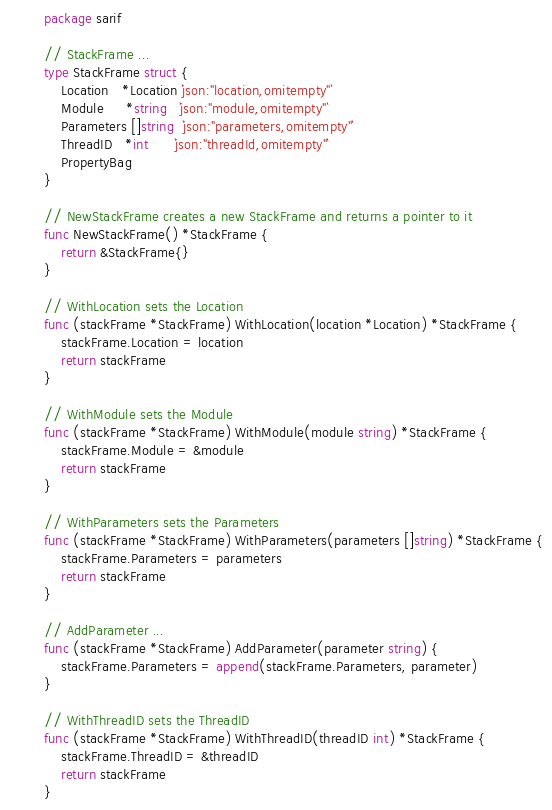Convert code to text. <code><loc_0><loc_0><loc_500><loc_500><_Go_>package sarif

// StackFrame ...
type StackFrame struct {
	Location   *Location `json:"location,omitempty"`
	Module     *string   `json:"module,omitempty"`
	Parameters []string  `json:"parameters,omitempty"`
	ThreadID   *int      `json:"threadId,omitempty"`
	PropertyBag
}

// NewStackFrame creates a new StackFrame and returns a pointer to it
func NewStackFrame() *StackFrame {
	return &StackFrame{}
}

// WithLocation sets the Location
func (stackFrame *StackFrame) WithLocation(location *Location) *StackFrame {
	stackFrame.Location = location
	return stackFrame
}

// WithModule sets the Module
func (stackFrame *StackFrame) WithModule(module string) *StackFrame {
	stackFrame.Module = &module
	return stackFrame
}

// WithParameters sets the Parameters
func (stackFrame *StackFrame) WithParameters(parameters []string) *StackFrame {
	stackFrame.Parameters = parameters
	return stackFrame
}

// AddParameter ...
func (stackFrame *StackFrame) AddParameter(parameter string) {
	stackFrame.Parameters = append(stackFrame.Parameters, parameter)
}

// WithThreadID sets the ThreadID
func (stackFrame *StackFrame) WithThreadID(threadID int) *StackFrame {
	stackFrame.ThreadID = &threadID
	return stackFrame
}
</code> 